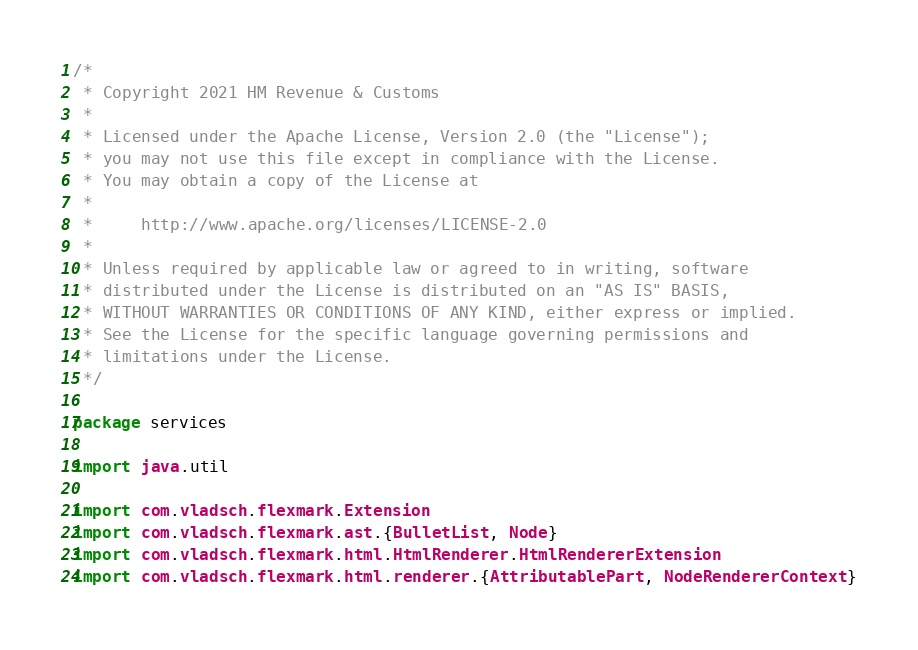Convert code to text. <code><loc_0><loc_0><loc_500><loc_500><_Scala_>/*
 * Copyright 2021 HM Revenue & Customs
 *
 * Licensed under the Apache License, Version 2.0 (the "License");
 * you may not use this file except in compliance with the License.
 * You may obtain a copy of the License at
 *
 *     http://www.apache.org/licenses/LICENSE-2.0
 *
 * Unless required by applicable law or agreed to in writing, software
 * distributed under the License is distributed on an "AS IS" BASIS,
 * WITHOUT WARRANTIES OR CONDITIONS OF ANY KIND, either express or implied.
 * See the License for the specific language governing permissions and
 * limitations under the License.
 */

package services

import java.util

import com.vladsch.flexmark.Extension
import com.vladsch.flexmark.ast.{BulletList, Node}
import com.vladsch.flexmark.html.HtmlRenderer.HtmlRendererExtension
import com.vladsch.flexmark.html.renderer.{AttributablePart, NodeRendererContext}</code> 